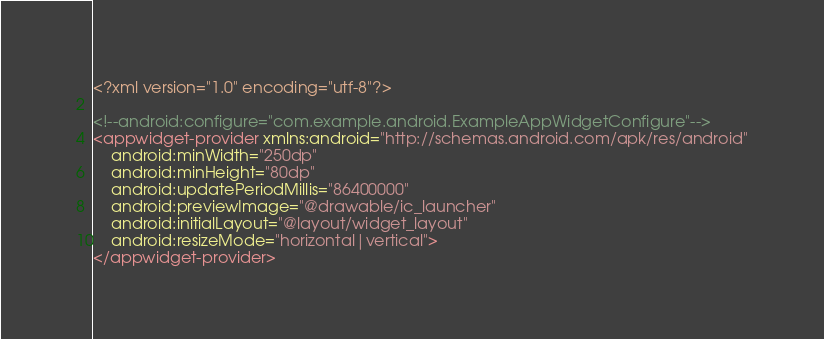Convert code to text. <code><loc_0><loc_0><loc_500><loc_500><_XML_><?xml version="1.0" encoding="utf-8"?>

<!--android:configure="com.example.android.ExampleAppWidgetConfigure"-->
<appwidget-provider xmlns:android="http://schemas.android.com/apk/res/android"
    android:minWidth="250dp"
    android:minHeight="80dp"
    android:updatePeriodMillis="86400000"
    android:previewImage="@drawable/ic_launcher"
    android:initialLayout="@layout/widget_layout"
    android:resizeMode="horizontal|vertical">
</appwidget-provider>
</code> 